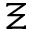Convert formula to latex. <formula><loc_0><loc_0><loc_500><loc_500>\Xi</formula> 